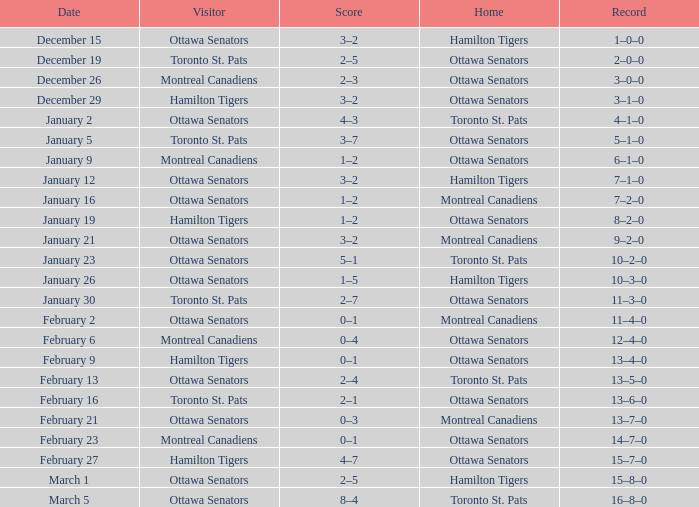Which home team had a visitor of Ottawa Senators with a score of 1–5? Hamilton Tigers. Could you parse the entire table as a dict? {'header': ['Date', 'Visitor', 'Score', 'Home', 'Record'], 'rows': [['December 15', 'Ottawa Senators', '3–2', 'Hamilton Tigers', '1–0–0'], ['December 19', 'Toronto St. Pats', '2–5', 'Ottawa Senators', '2–0–0'], ['December 26', 'Montreal Canadiens', '2–3', 'Ottawa Senators', '3–0–0'], ['December 29', 'Hamilton Tigers', '3–2', 'Ottawa Senators', '3–1–0'], ['January 2', 'Ottawa Senators', '4–3', 'Toronto St. Pats', '4–1–0'], ['January 5', 'Toronto St. Pats', '3–7', 'Ottawa Senators', '5–1–0'], ['January 9', 'Montreal Canadiens', '1–2', 'Ottawa Senators', '6–1–0'], ['January 12', 'Ottawa Senators', '3–2', 'Hamilton Tigers', '7–1–0'], ['January 16', 'Ottawa Senators', '1–2', 'Montreal Canadiens', '7–2–0'], ['January 19', 'Hamilton Tigers', '1–2', 'Ottawa Senators', '8–2–0'], ['January 21', 'Ottawa Senators', '3–2', 'Montreal Canadiens', '9–2–0'], ['January 23', 'Ottawa Senators', '5–1', 'Toronto St. Pats', '10–2–0'], ['January 26', 'Ottawa Senators', '1–5', 'Hamilton Tigers', '10–3–0'], ['January 30', 'Toronto St. Pats', '2–7', 'Ottawa Senators', '11–3–0'], ['February 2', 'Ottawa Senators', '0–1', 'Montreal Canadiens', '11–4–0'], ['February 6', 'Montreal Canadiens', '0–4', 'Ottawa Senators', '12–4–0'], ['February 9', 'Hamilton Tigers', '0–1', 'Ottawa Senators', '13–4–0'], ['February 13', 'Ottawa Senators', '2–4', 'Toronto St. Pats', '13–5–0'], ['February 16', 'Toronto St. Pats', '2–1', 'Ottawa Senators', '13–6–0'], ['February 21', 'Ottawa Senators', '0–3', 'Montreal Canadiens', '13–7–0'], ['February 23', 'Montreal Canadiens', '0–1', 'Ottawa Senators', '14–7–0'], ['February 27', 'Hamilton Tigers', '4–7', 'Ottawa Senators', '15–7–0'], ['March 1', 'Ottawa Senators', '2–5', 'Hamilton Tigers', '15–8–0'], ['March 5', 'Ottawa Senators', '8–4', 'Toronto St. Pats', '16–8–0']]} 